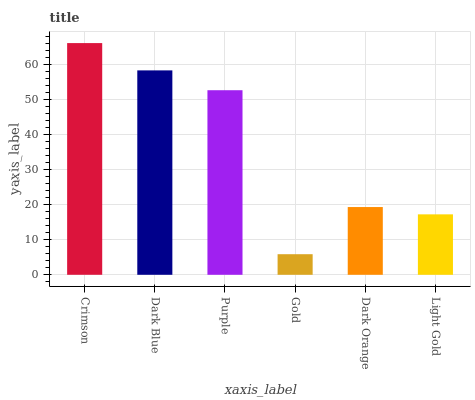Is Gold the minimum?
Answer yes or no. Yes. Is Crimson the maximum?
Answer yes or no. Yes. Is Dark Blue the minimum?
Answer yes or no. No. Is Dark Blue the maximum?
Answer yes or no. No. Is Crimson greater than Dark Blue?
Answer yes or no. Yes. Is Dark Blue less than Crimson?
Answer yes or no. Yes. Is Dark Blue greater than Crimson?
Answer yes or no. No. Is Crimson less than Dark Blue?
Answer yes or no. No. Is Purple the high median?
Answer yes or no. Yes. Is Dark Orange the low median?
Answer yes or no. Yes. Is Dark Blue the high median?
Answer yes or no. No. Is Dark Blue the low median?
Answer yes or no. No. 